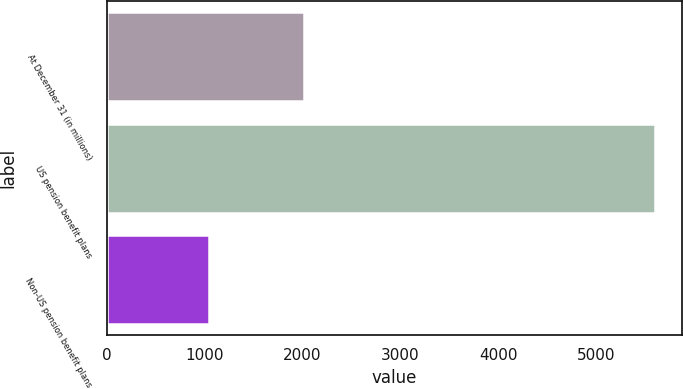Convert chart. <chart><loc_0><loc_0><loc_500><loc_500><bar_chart><fcel>At December 31 (in millions)<fcel>US pension benefit plans<fcel>Non-US pension benefit plans<nl><fcel>2014<fcel>5601<fcel>1040<nl></chart> 